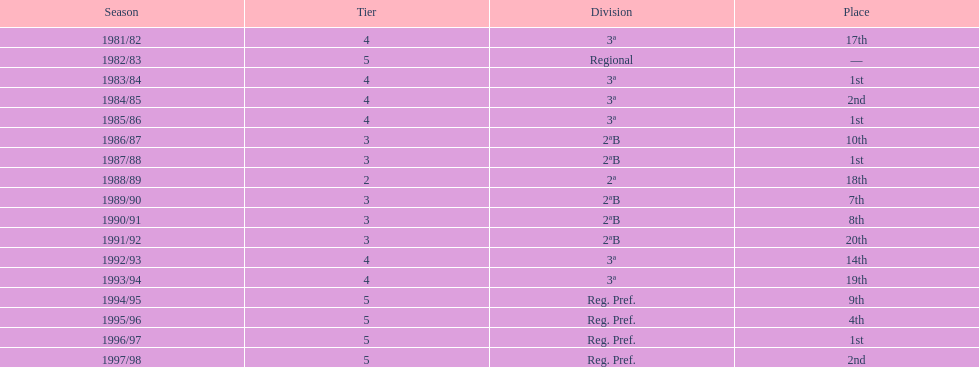How many times in total did they come in first place? 4. 